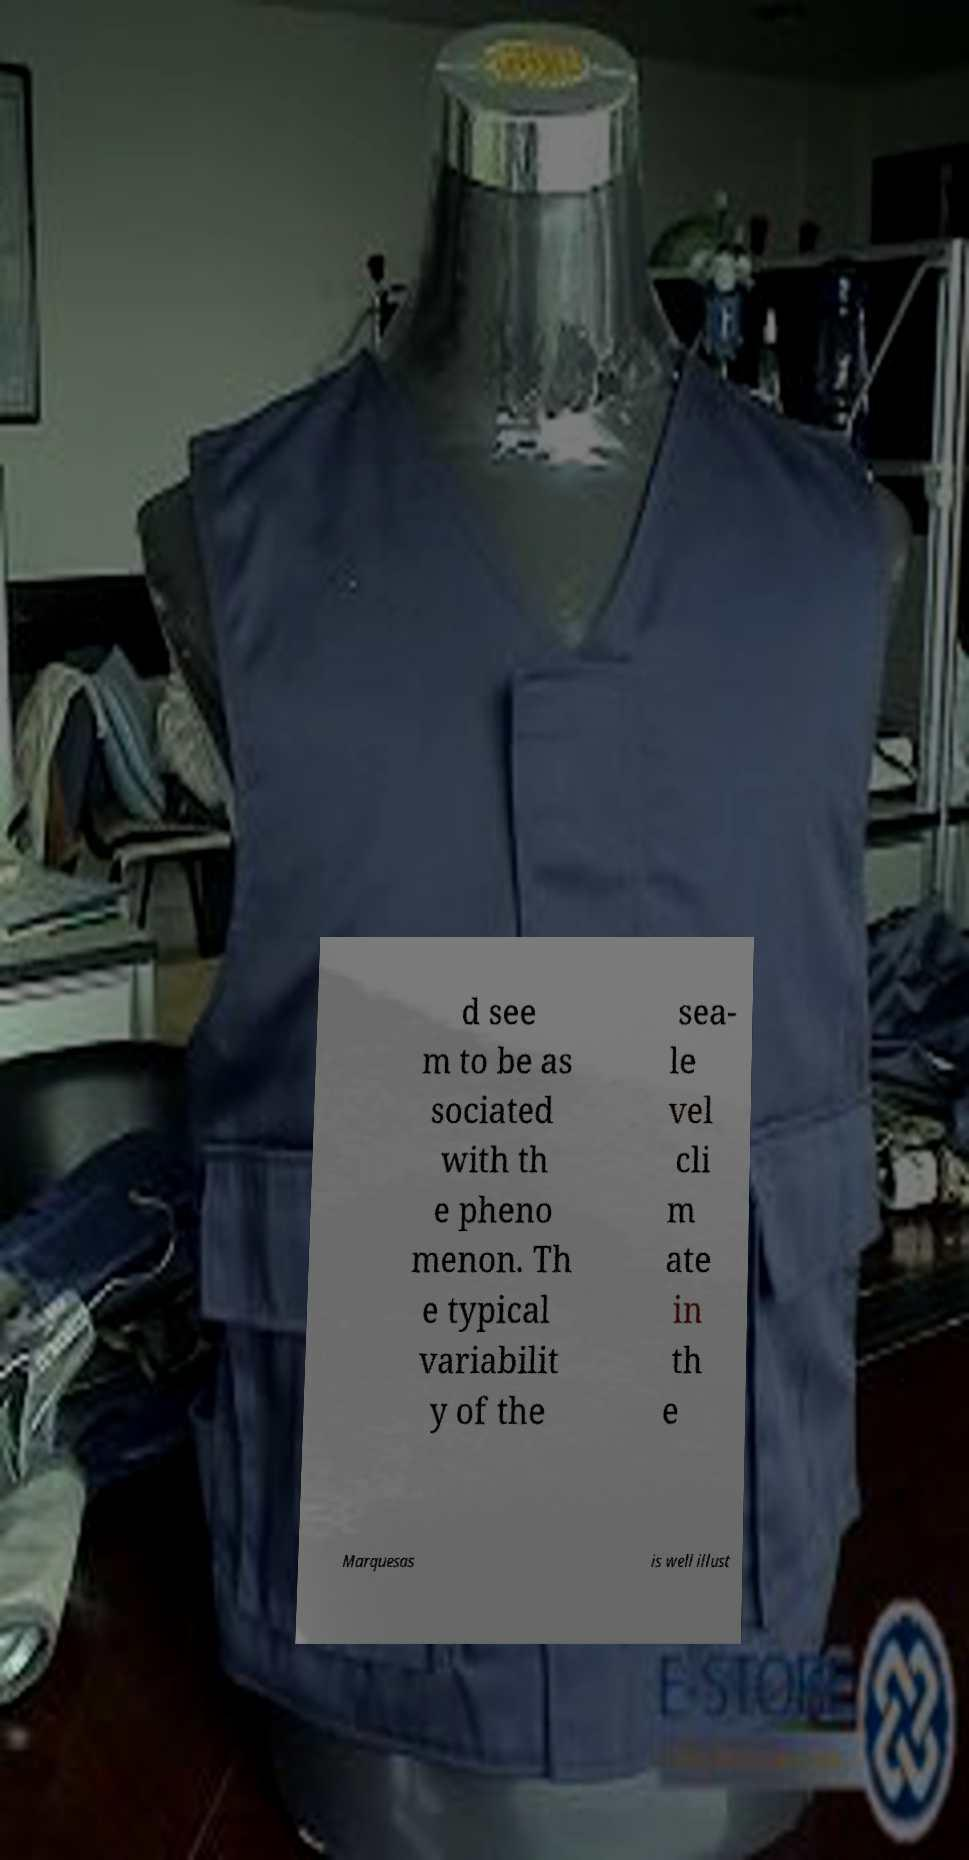Can you read and provide the text displayed in the image?This photo seems to have some interesting text. Can you extract and type it out for me? d see m to be as sociated with th e pheno menon. Th e typical variabilit y of the sea- le vel cli m ate in th e Marquesas is well illust 